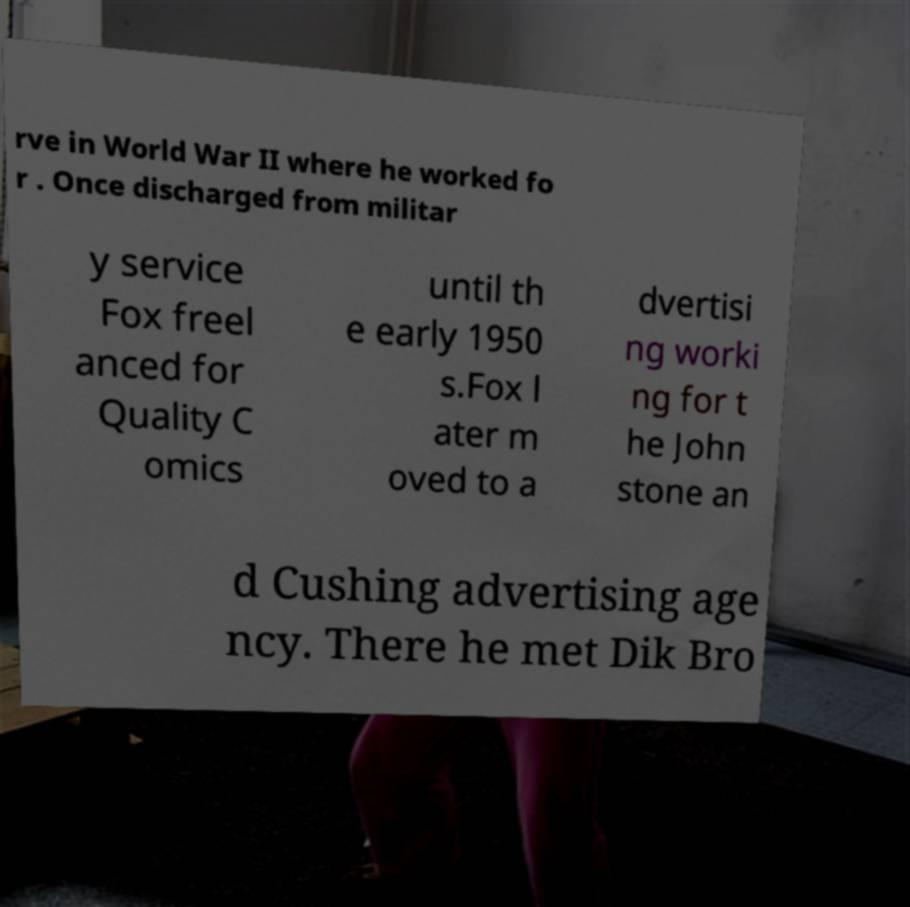I need the written content from this picture converted into text. Can you do that? rve in World War II where he worked fo r . Once discharged from militar y service Fox freel anced for Quality C omics until th e early 1950 s.Fox l ater m oved to a dvertisi ng worki ng for t he John stone an d Cushing advertising age ncy. There he met Dik Bro 